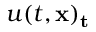Convert formula to latex. <formula><loc_0><loc_0><loc_500><loc_500>u ( t , x ) _ { t }</formula> 